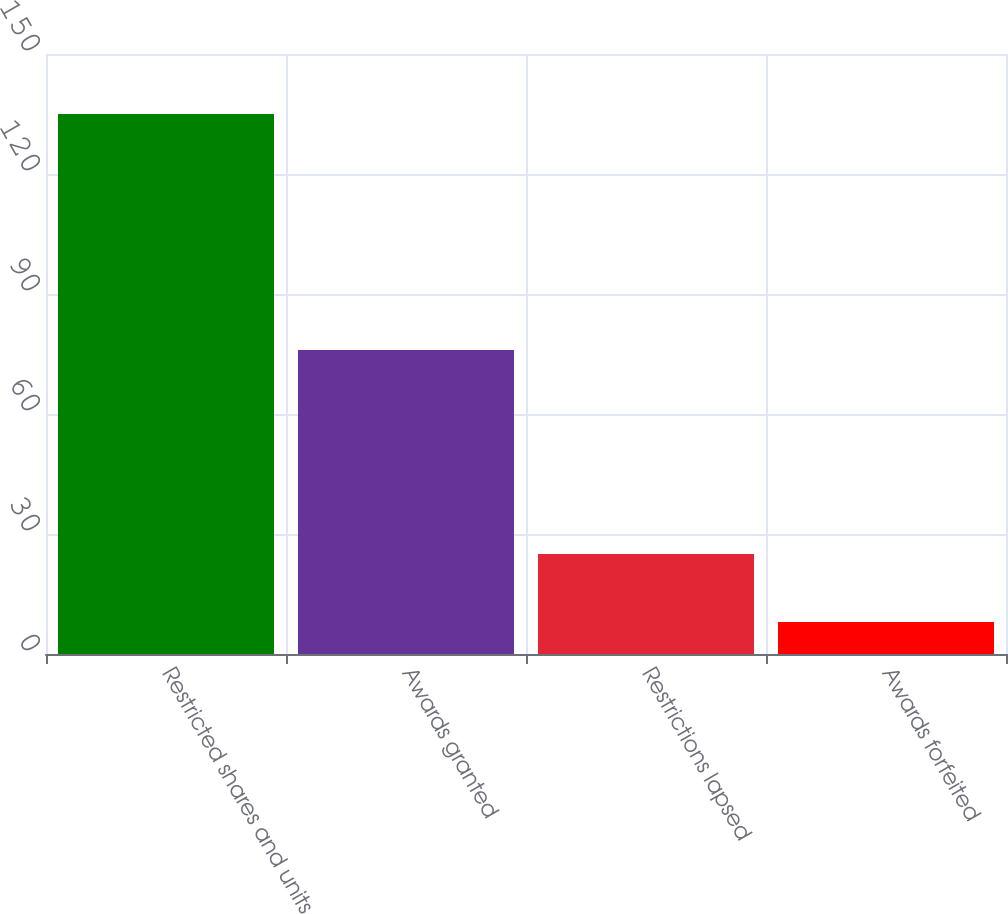Convert chart to OTSL. <chart><loc_0><loc_0><loc_500><loc_500><bar_chart><fcel>Restricted shares and units<fcel>Awards granted<fcel>Restrictions lapsed<fcel>Awards forfeited<nl><fcel>135<fcel>76<fcel>25<fcel>8<nl></chart> 